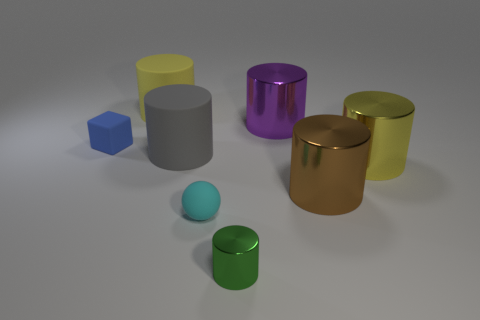Subtract all brown metallic cylinders. How many cylinders are left? 5 Subtract 1 blocks. How many blocks are left? 0 Add 1 big brown matte balls. How many objects exist? 9 Subtract all brown cylinders. How many cylinders are left? 5 Subtract all spheres. How many objects are left? 7 Subtract 0 red blocks. How many objects are left? 8 Subtract all gray balls. Subtract all purple blocks. How many balls are left? 1 Subtract all blue cubes. How many cyan cylinders are left? 0 Subtract all gray matte balls. Subtract all blue objects. How many objects are left? 7 Add 1 big gray matte cylinders. How many big gray matte cylinders are left? 2 